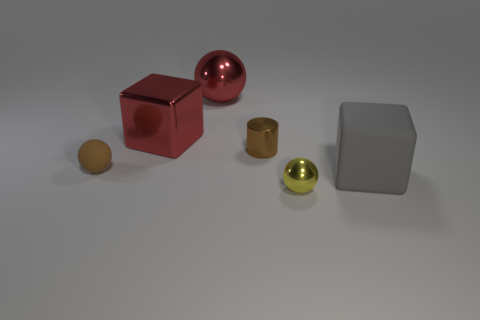There is a metal thing that is both in front of the large red cube and behind the small brown matte ball; how big is it? The metal object situated between the large red cube and the small brown matte ball appears to be a medium-sized metal cylindrical container. Its size is moderate compared to the other objects, neither the smallest nor the largest among them. 